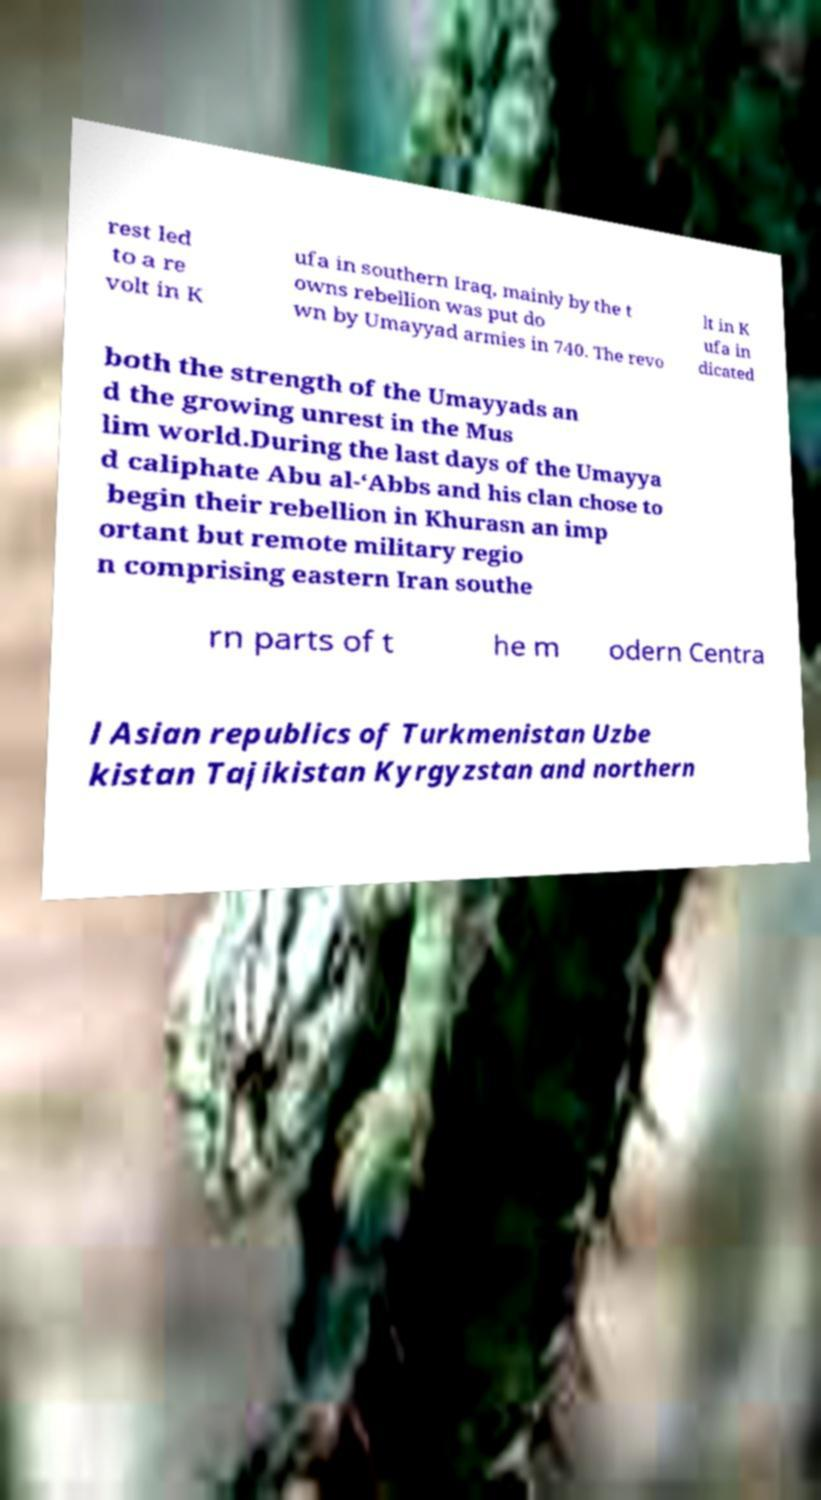Can you read and provide the text displayed in the image?This photo seems to have some interesting text. Can you extract and type it out for me? rest led to a re volt in K ufa in southern Iraq, mainly by the t owns rebellion was put do wn by Umayyad armies in 740. The revo lt in K ufa in dicated both the strength of the Umayyads an d the growing unrest in the Mus lim world.During the last days of the Umayya d caliphate Abu al-‘Abbs and his clan chose to begin their rebellion in Khurasn an imp ortant but remote military regio n comprising eastern Iran southe rn parts of t he m odern Centra l Asian republics of Turkmenistan Uzbe kistan Tajikistan Kyrgyzstan and northern 